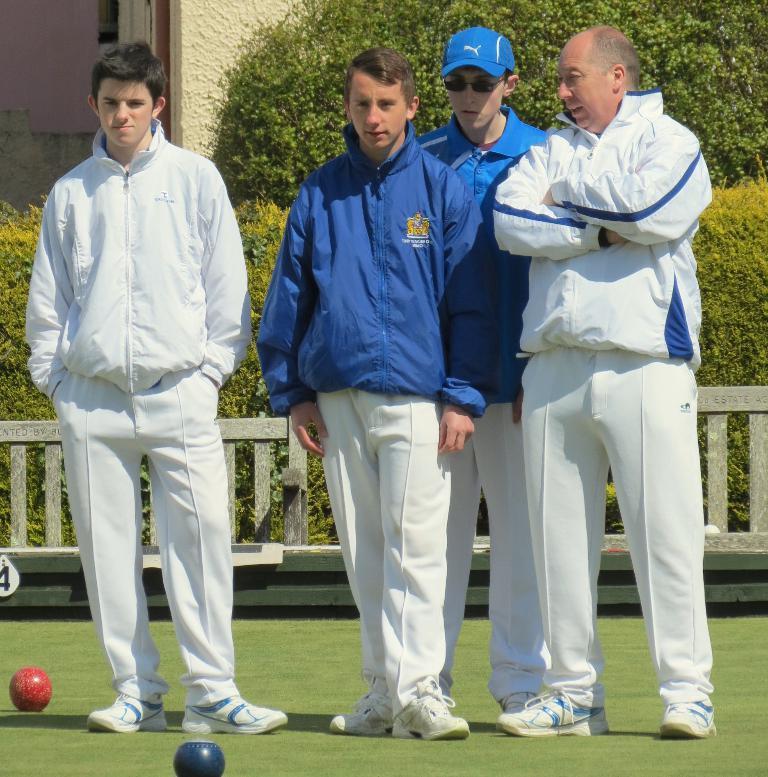How would you summarize this image in a sentence or two? In this image we can see some persons. In the background of the image there is a fence, plants, trees, building and other objects. At the bottom of the image there is the floor and balls. 